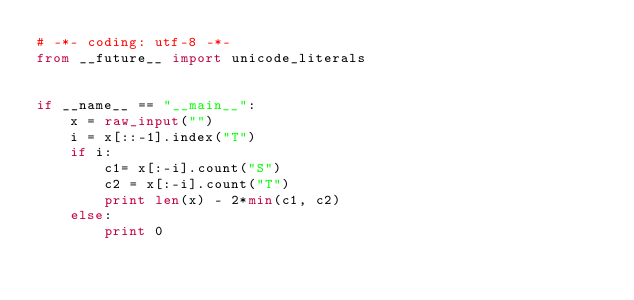Convert code to text. <code><loc_0><loc_0><loc_500><loc_500><_Python_># -*- coding: utf-8 -*-
from __future__ import unicode_literals


if __name__ == "__main__":
    x = raw_input("")
    i = x[::-1].index("T")
    if i:
        c1= x[:-i].count("S")
        c2 = x[:-i].count("T")
        print len(x) - 2*min(c1, c2)
    else:
        print 0
</code> 